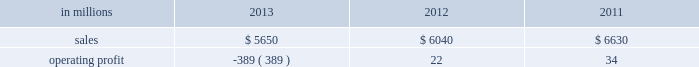Input costs for board and resin are expected to be flat and operating costs are expected to decrease .
European consumer packaging net sales in 2013 were $ 380 million compared with $ 380 million in 2012 and $ 375 million in 2011 .
Operating profits in 2013 were $ 100 million compared with $ 99 million in 2012 and $ 93 million in 2011 .
Sales volumes in 2013 decreased from 2012 in both the european and russian markets .
Average sales price realizations were significantly higher in the russian market , but were lower in europe .
Input costs were flat year-over-year .
Planned maintenance downtime costs were higher in 2013 than in 2012 .
Looking forward to the first quarter of 2014 , sales volumes compared with the fourth quarter of 2013 are expected to be about flat .
Average sales price realizations are expected to be higher in both russia and europe .
Input costs are expected to increase for wood and energy , but decrease for purchased pulp .
There are no maintenance outages scheduled for the first quarter , however the kwidzyn mill will have additional costs associated with the rebuild of a coated board machine .
Asian consumer packaging net sales were $ 1.1 billion in 2013 compared with $ 830 million in 2012 and $ 855 million in 2011 .
Operating profits in 2013 were a loss of $ 2 million compared with gains of $ 4 million in 2012 and $ 35 million in 2011 .
Sales volumes increased in 2013 compared with 2012 , reflecting the ramp-up of a new coated paperboard machine installed in 2012 .
However , average sales price realizations were significantly lower , reflecting competitive pressure on sales prices which squeezed margins and created an unfavorable product mix .
Lower input costs were offset by higher freight costs .
In 2012 , start-up costs for the new coated paperboard machine adversely impacted operating profits .
In the first quarter of 2014 , sales volumes are expected to increase slightly .
Average sales price realizations are expected to be flat reflecting continuing competitive pressures .
Input costs are expected be higher for pulp , energy and chemicals .
The business will drive margin improvement through operational excellence and better distribution xpedx , our distribution business , is one of north america 2019s leading business-to-business distributors to manufacturers , facility managers and printers , providing customized solutions that are designed to improve efficiency , reduce costs and deliver results .
Customer demand is generally sensitive to changes in economic conditions and consumer behavior , along with segment specific activity including corporate advertising and promotional spending , government spending and domestic manufacturing activity .
Distribution 2019s margins are relatively stable across an economic cycle .
Providing customers with the best choice for value in both products and supply chain services is a key competitive factor .
Additionally , efficient customer service , cost-effective logistics and focused working capital management are key factors in this segment 2019s profitability .
Distribution .
Distribution 2019s 2013 annual sales decreased 6% ( 6 % ) from 2012 , and decreased 15% ( 15 % ) from 2011 .
Operating profits in 2013 were a loss of $ 389 million ( a gain of $ 43 million excluding goodwill impairment charges and reorganization costs ) compared with $ 22 million ( $ 71 million excluding reorganization costs ) in 2012 and $ 34 million ( $ 86 million excluding reorganization costs ) in annual sales of printing papers and graphic arts supplies and equipment totaled $ 3.2 billion in 2013 compared with $ 3.5 billion in 2012 and $ 4.0 billion in 2011 reflecting declining demand and the discontinuation of a distribution agreement with a large manufacturer of graphic supplies .
Trade margins as a percent of sales for printing papers were down from both 2012 and 2011 .
Revenue from packaging products was flat at $ 1.6 billion in 2013 , 2012 and 2011 despite the significant decline of a large high-tech customer's business .
Packaging margins remained flat to the 2012 level , and up from 2011 .
Facility supplies annual revenue was $ 845 million in 2013 , down from $ 944 million in 2012 and $ 981 million in 2011 .
Operating profits in 2013 included a goodwill impairment charge of $ 400 million and reorganization costs for severance , professional services and asset write-downs of $ 32 million .
Operating profits in 2012 and 2011 included reorganization costs of $ 49 million and $ 52 million , respectively .
Looking ahead to the 2014 first quarter , operating profits will be seasonally lower , but will continue to reflect the benefits of strategic and other cost reduction initiatives. .
What was the percentage change in the asian consumer packaging net sales in 2013? 
Computations: ((1.1 - 830) / 830)
Answer: -0.99867. 